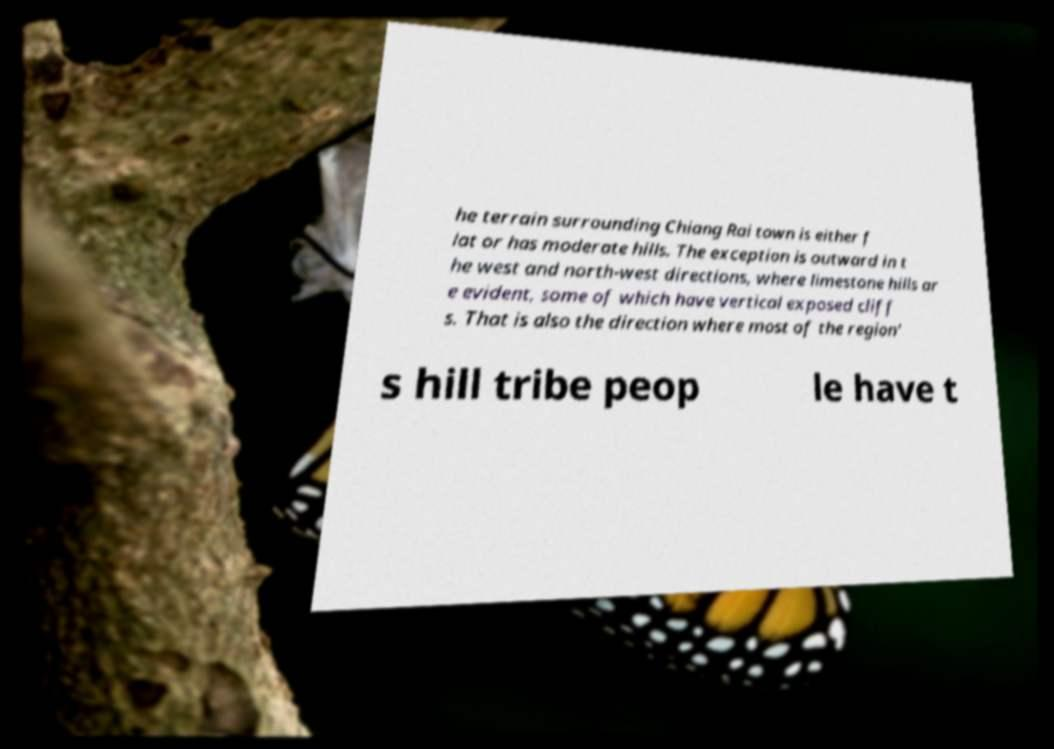Please identify and transcribe the text found in this image. he terrain surrounding Chiang Rai town is either f lat or has moderate hills. The exception is outward in t he west and north-west directions, where limestone hills ar e evident, some of which have vertical exposed cliff s. That is also the direction where most of the region' s hill tribe peop le have t 